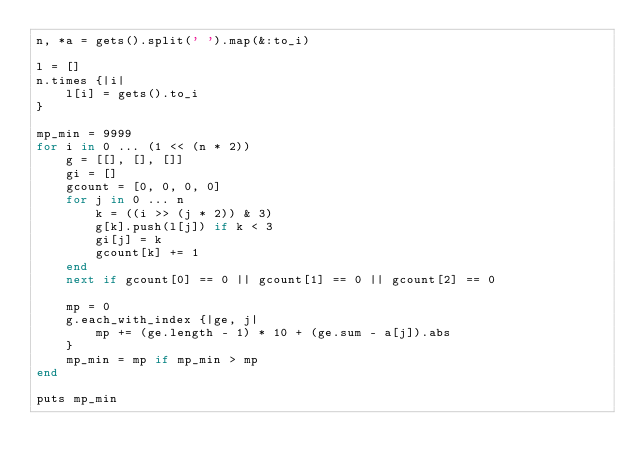<code> <loc_0><loc_0><loc_500><loc_500><_Ruby_>n, *a = gets().split(' ').map(&:to_i)

l = []
n.times {|i|
	l[i] = gets().to_i
}

mp_min = 9999
for i in 0 ... (1 << (n * 2))
	g = [[], [], []]
	gi = []
	gcount = [0, 0, 0, 0]
	for j in 0 ... n
		k = ((i >> (j * 2)) & 3)
		g[k].push(l[j]) if k < 3
		gi[j] = k
		gcount[k] += 1
	end
	next if gcount[0] == 0 || gcount[1] == 0 || gcount[2] == 0

	mp = 0
	g.each_with_index {|ge, j|
		mp += (ge.length - 1) * 10 + (ge.sum - a[j]).abs
	}
	mp_min = mp if mp_min > mp
end

puts mp_min
</code> 